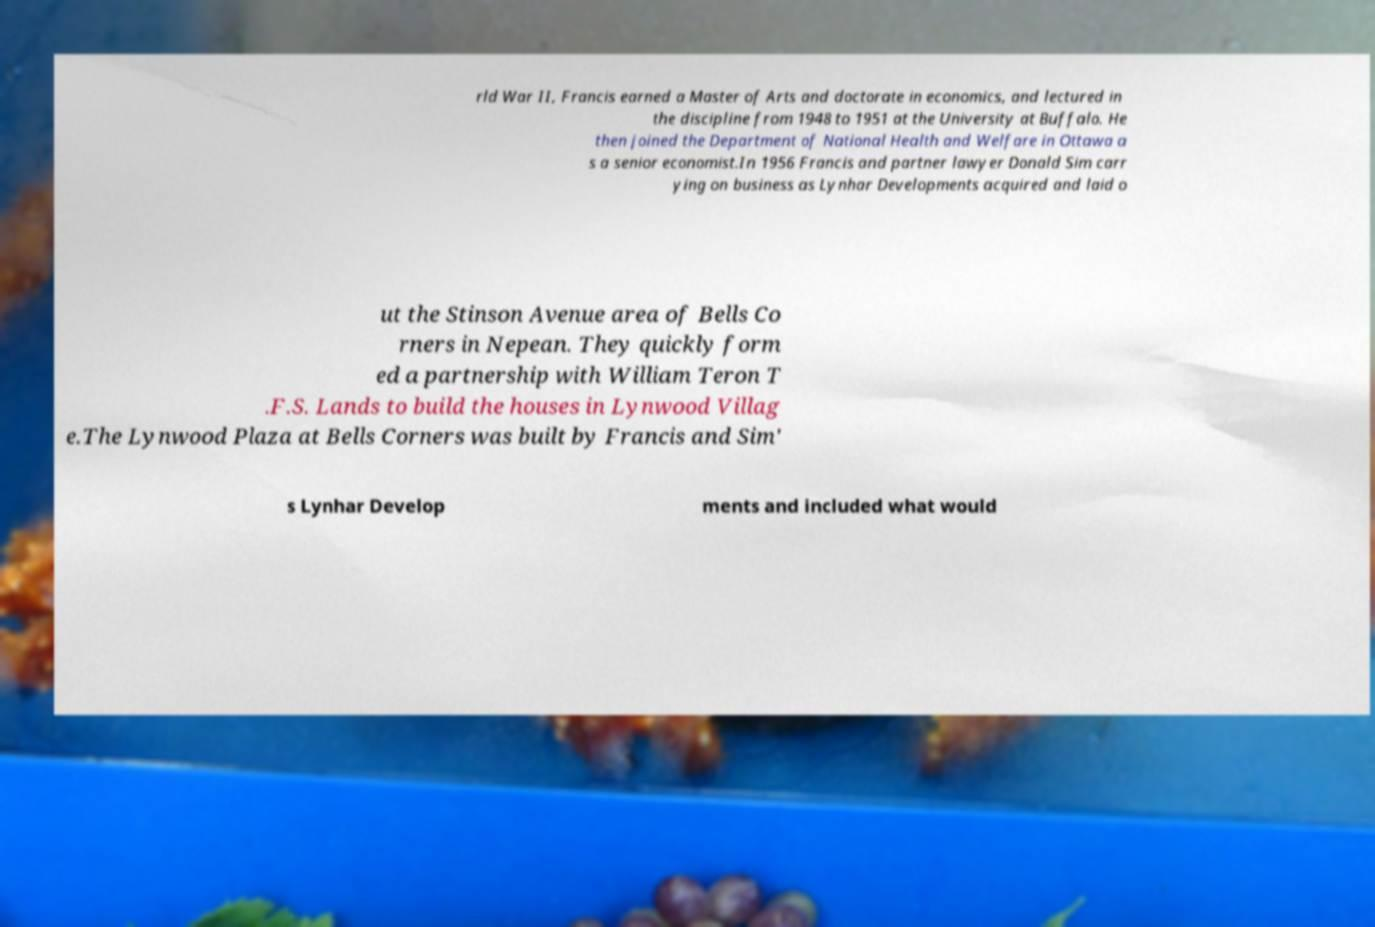Please identify and transcribe the text found in this image. rld War II, Francis earned a Master of Arts and doctorate in economics, and lectured in the discipline from 1948 to 1951 at the University at Buffalo. He then joined the Department of National Health and Welfare in Ottawa a s a senior economist.In 1956 Francis and partner lawyer Donald Sim carr ying on business as Lynhar Developments acquired and laid o ut the Stinson Avenue area of Bells Co rners in Nepean. They quickly form ed a partnership with William Teron T .F.S. Lands to build the houses in Lynwood Villag e.The Lynwood Plaza at Bells Corners was built by Francis and Sim' s Lynhar Develop ments and included what would 